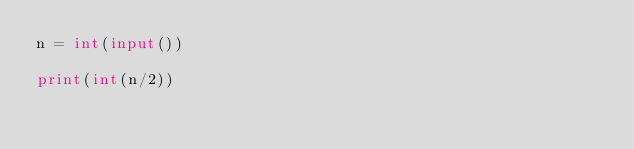<code> <loc_0><loc_0><loc_500><loc_500><_Python_>n = int(input())

print(int(n/2))
</code> 